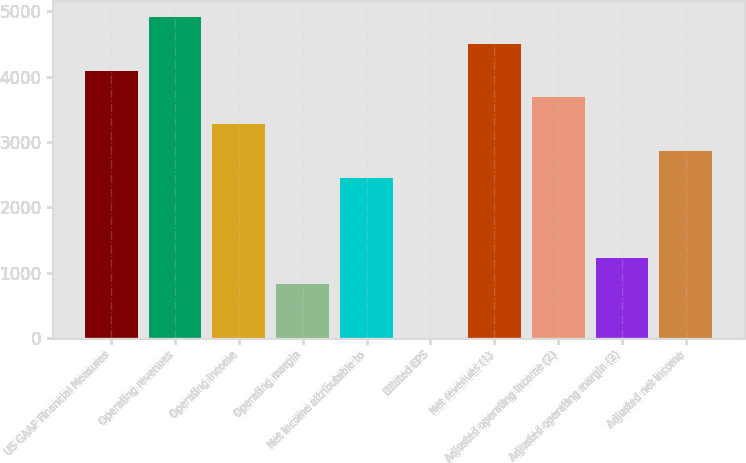Convert chart to OTSL. <chart><loc_0><loc_0><loc_500><loc_500><bar_chart><fcel>US GAAP Financial Measures<fcel>Operating revenues<fcel>Operating income<fcel>Operating margin<fcel>Net income attributable to<fcel>Diluted EPS<fcel>Net revenues (1)<fcel>Adjusted operating income (2)<fcel>Adjusted operating margin (2)<fcel>Adjusted net income<nl><fcel>4092.17<fcel>4910.29<fcel>3274.05<fcel>819.69<fcel>2455.93<fcel>1.57<fcel>4501.23<fcel>3683.11<fcel>1228.75<fcel>2864.99<nl></chart> 